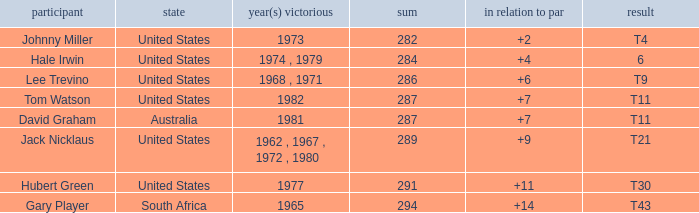WHAT IS THE TOTAL THAT HAS A WIN IN 1982? 287.0. 